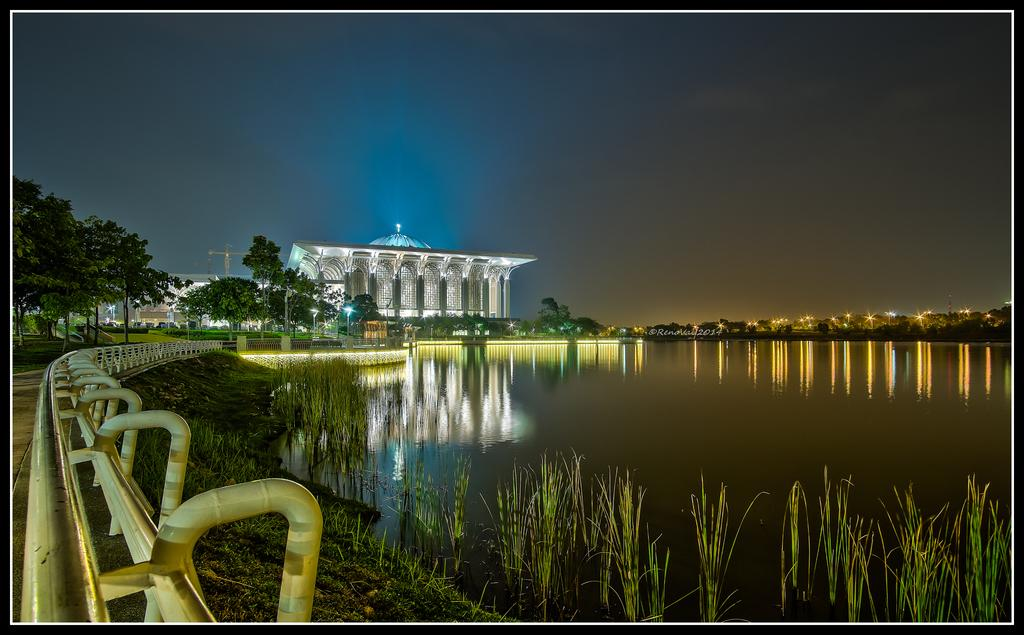What is located in the center of the image? There is water, plants, and fences in the center of the image. What can be seen in the background of the image? The sky, buildings, lights, and trees are visible in the background of the image. How many elements are present in the center of the image? There are three elements present in the center: water, plants, and fences. What type of natural elements are visible in the image? Water, plants, and trees are visible in the image. Where is the jelly located in the image? There is no jelly present in the image. What type of sidewalk can be seen near the water in the image? There is no sidewalk present in the image. 